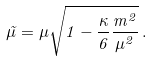<formula> <loc_0><loc_0><loc_500><loc_500>\tilde { \mu } = \mu \sqrt { 1 - \frac { \kappa } { 6 } \frac { m ^ { 2 } } { \mu ^ { 2 } } } \, .</formula> 